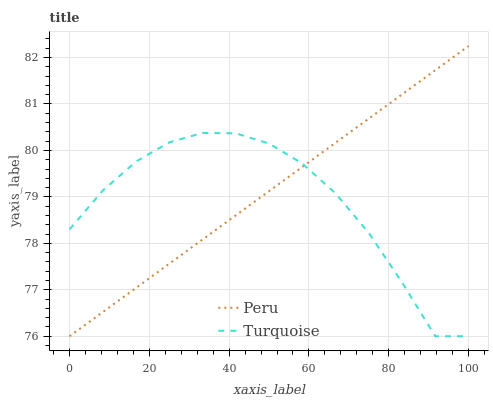Does Turquoise have the minimum area under the curve?
Answer yes or no. Yes. Does Peru have the maximum area under the curve?
Answer yes or no. Yes. Does Peru have the minimum area under the curve?
Answer yes or no. No. Is Peru the smoothest?
Answer yes or no. Yes. Is Turquoise the roughest?
Answer yes or no. Yes. Is Peru the roughest?
Answer yes or no. No. Does Peru have the highest value?
Answer yes or no. Yes. Does Turquoise intersect Peru?
Answer yes or no. Yes. Is Turquoise less than Peru?
Answer yes or no. No. Is Turquoise greater than Peru?
Answer yes or no. No. 